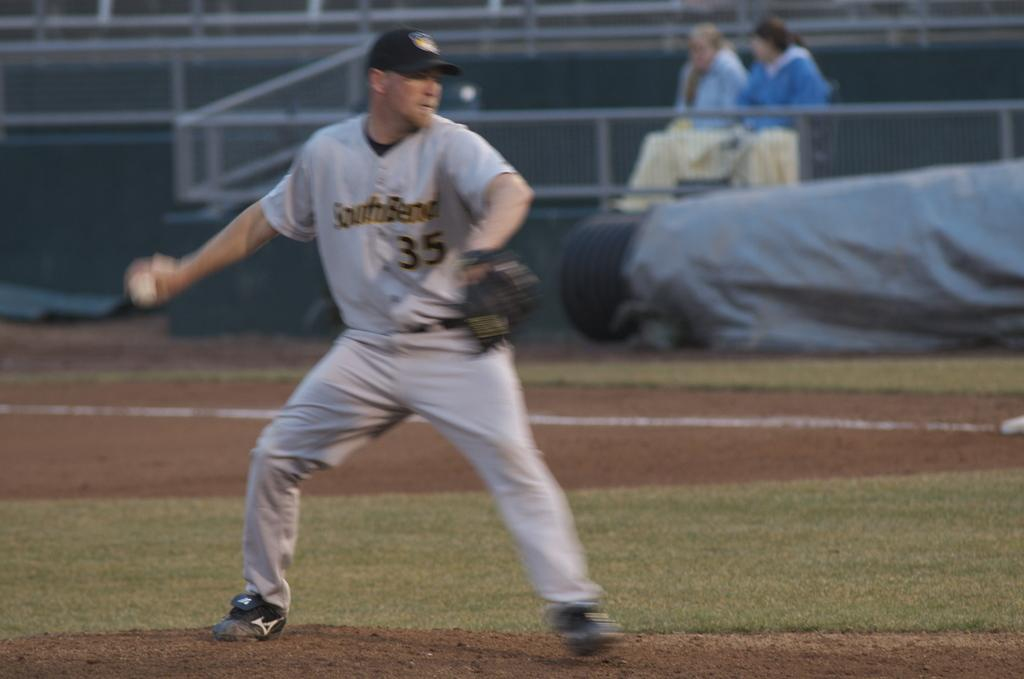<image>
Describe the image concisely. Player 35 of SouthBend prepares to throw a ball. 